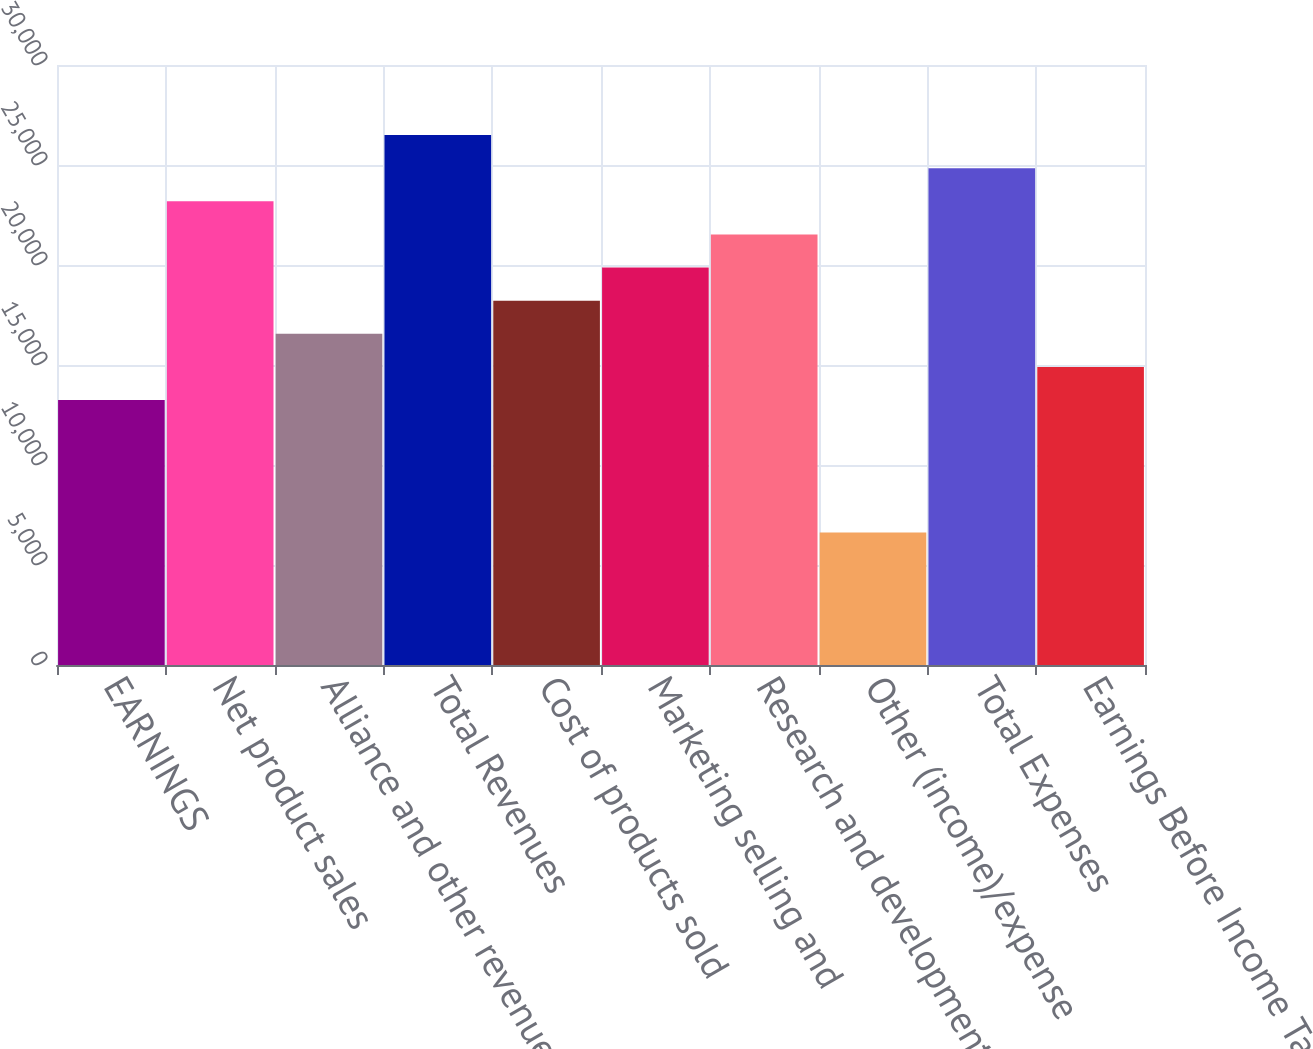Convert chart to OTSL. <chart><loc_0><loc_0><loc_500><loc_500><bar_chart><fcel>EARNINGS<fcel>Net product sales<fcel>Alliance and other revenues<fcel>Total Revenues<fcel>Cost of products sold<fcel>Marketing selling and<fcel>Research and development<fcel>Other (income)/expense<fcel>Total Expenses<fcel>Earnings Before Income Taxes<nl><fcel>13248.2<fcel>23183.7<fcel>16560<fcel>26495.5<fcel>18215.9<fcel>19871.8<fcel>21527.8<fcel>6624.57<fcel>24839.6<fcel>14904.1<nl></chart> 